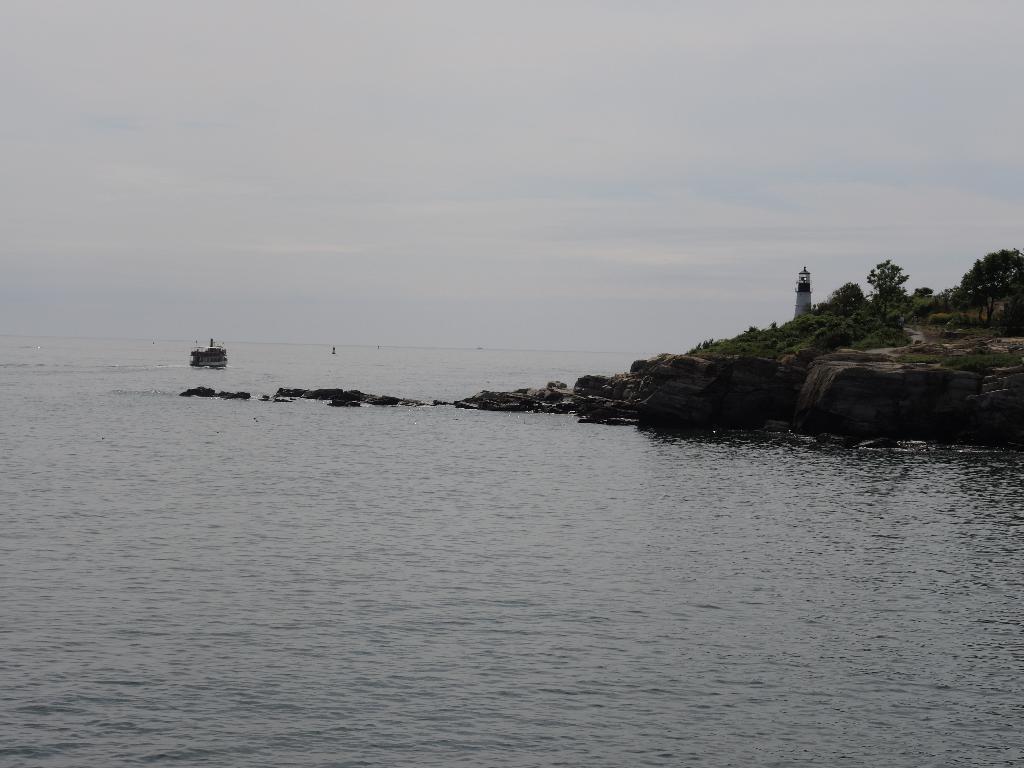In one or two sentences, can you explain what this image depicts? In this picture I can see the water at the bottom, on the right side there are trees and it looks like a tower. In the background I can see a boat on the water. At the top there is the sky. 